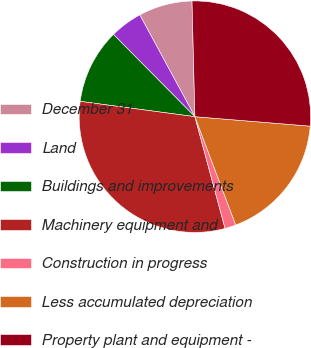Convert chart. <chart><loc_0><loc_0><loc_500><loc_500><pie_chart><fcel>December 31<fcel>Land<fcel>Buildings and improvements<fcel>Machinery equipment and<fcel>Construction in progress<fcel>Less accumulated depreciation<fcel>Property plant and equipment -<nl><fcel>7.5%<fcel>4.52%<fcel>10.47%<fcel>31.31%<fcel>1.54%<fcel>17.96%<fcel>26.7%<nl></chart> 